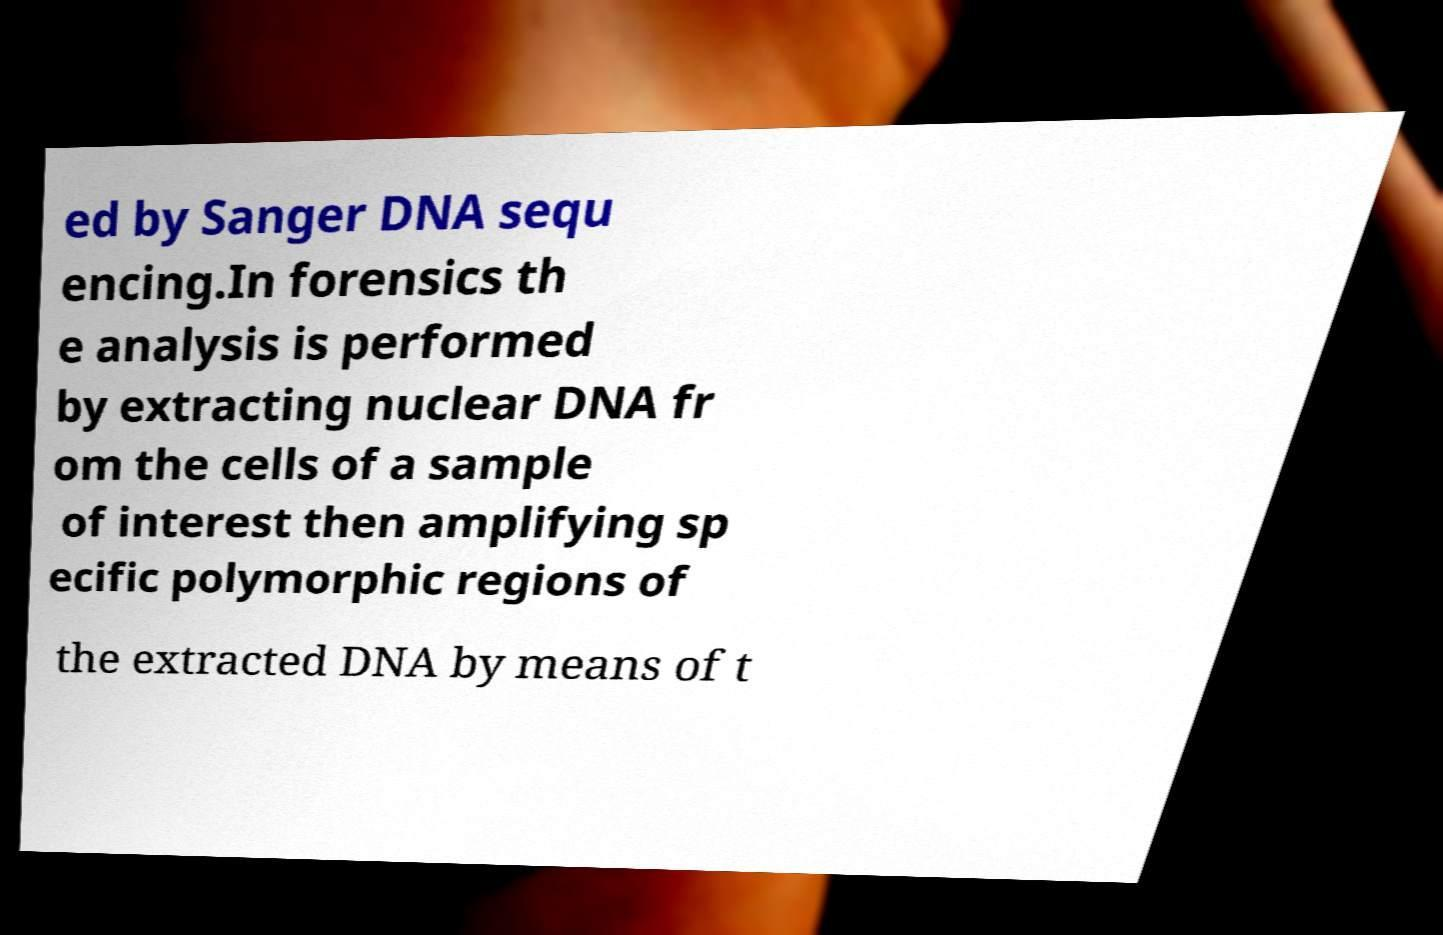Can you accurately transcribe the text from the provided image for me? ed by Sanger DNA sequ encing.In forensics th e analysis is performed by extracting nuclear DNA fr om the cells of a sample of interest then amplifying sp ecific polymorphic regions of the extracted DNA by means of t 